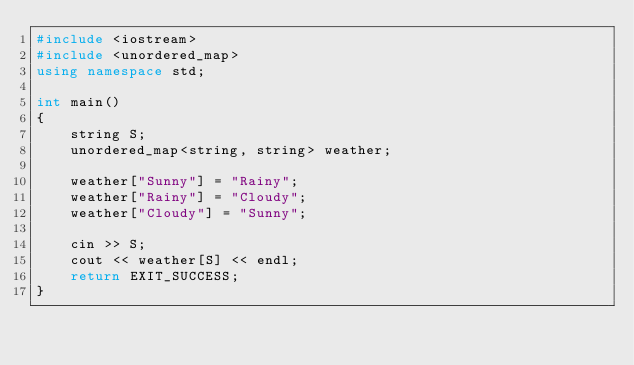<code> <loc_0><loc_0><loc_500><loc_500><_C++_>#include <iostream>
#include <unordered_map>
using namespace std;

int main()
{
    string S;
    unordered_map<string, string> weather;

    weather["Sunny"] = "Rainy";
    weather["Rainy"] = "Cloudy";
    weather["Cloudy"] = "Sunny";

    cin >> S;
    cout << weather[S] << endl;
    return EXIT_SUCCESS;
}</code> 